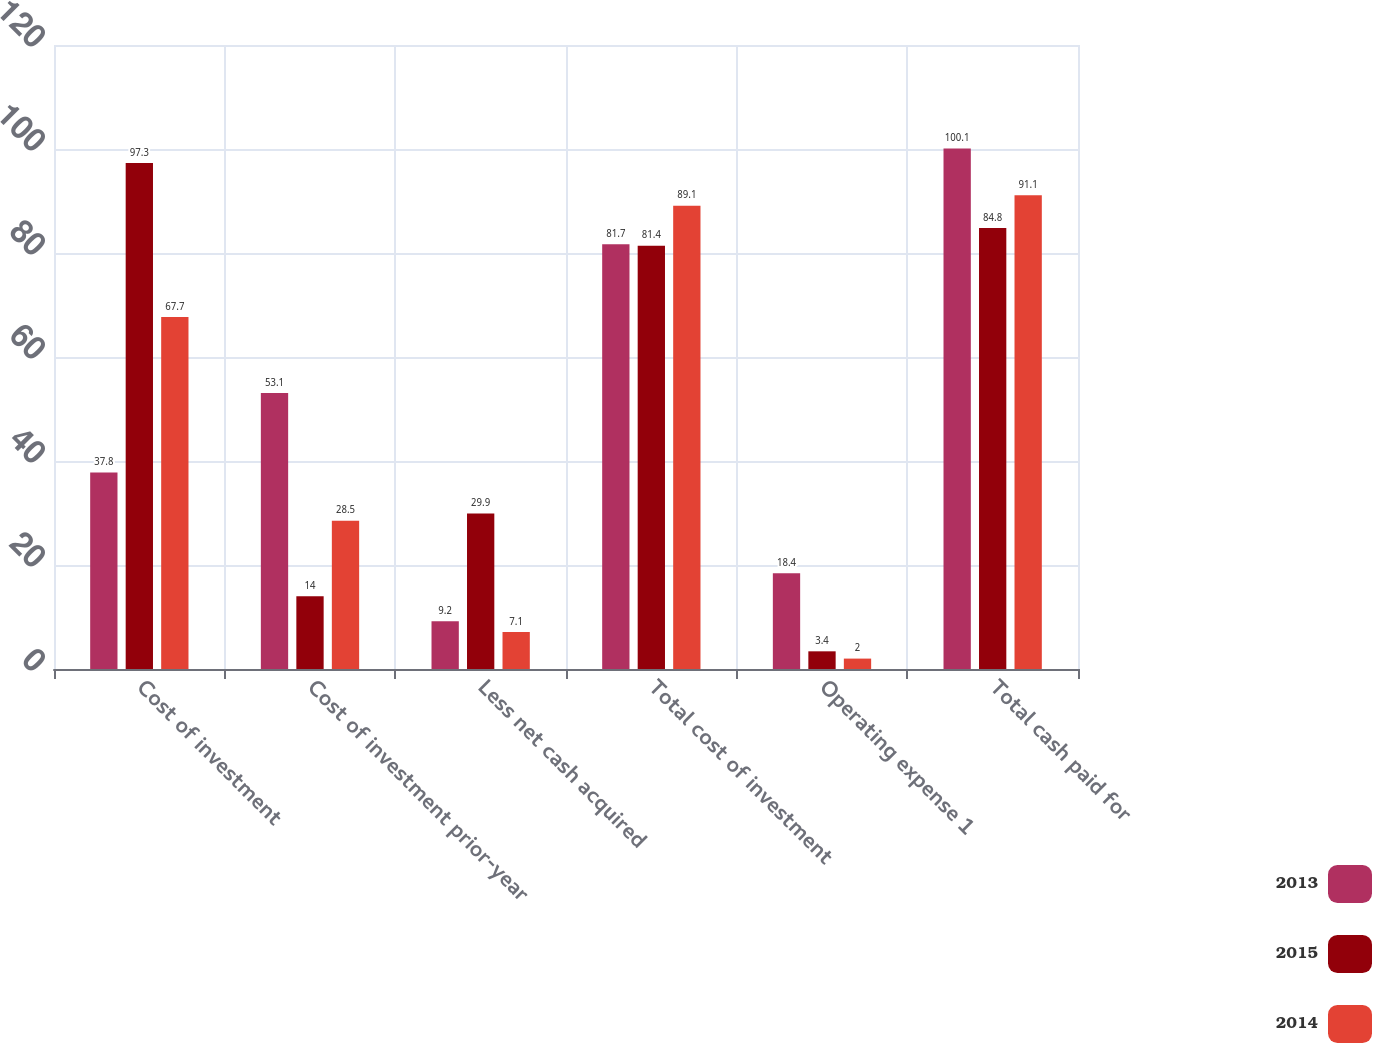Convert chart. <chart><loc_0><loc_0><loc_500><loc_500><stacked_bar_chart><ecel><fcel>Cost of investment<fcel>Cost of investment prior-year<fcel>Less net cash acquired<fcel>Total cost of investment<fcel>Operating expense 1<fcel>Total cash paid for<nl><fcel>2013<fcel>37.8<fcel>53.1<fcel>9.2<fcel>81.7<fcel>18.4<fcel>100.1<nl><fcel>2015<fcel>97.3<fcel>14<fcel>29.9<fcel>81.4<fcel>3.4<fcel>84.8<nl><fcel>2014<fcel>67.7<fcel>28.5<fcel>7.1<fcel>89.1<fcel>2<fcel>91.1<nl></chart> 